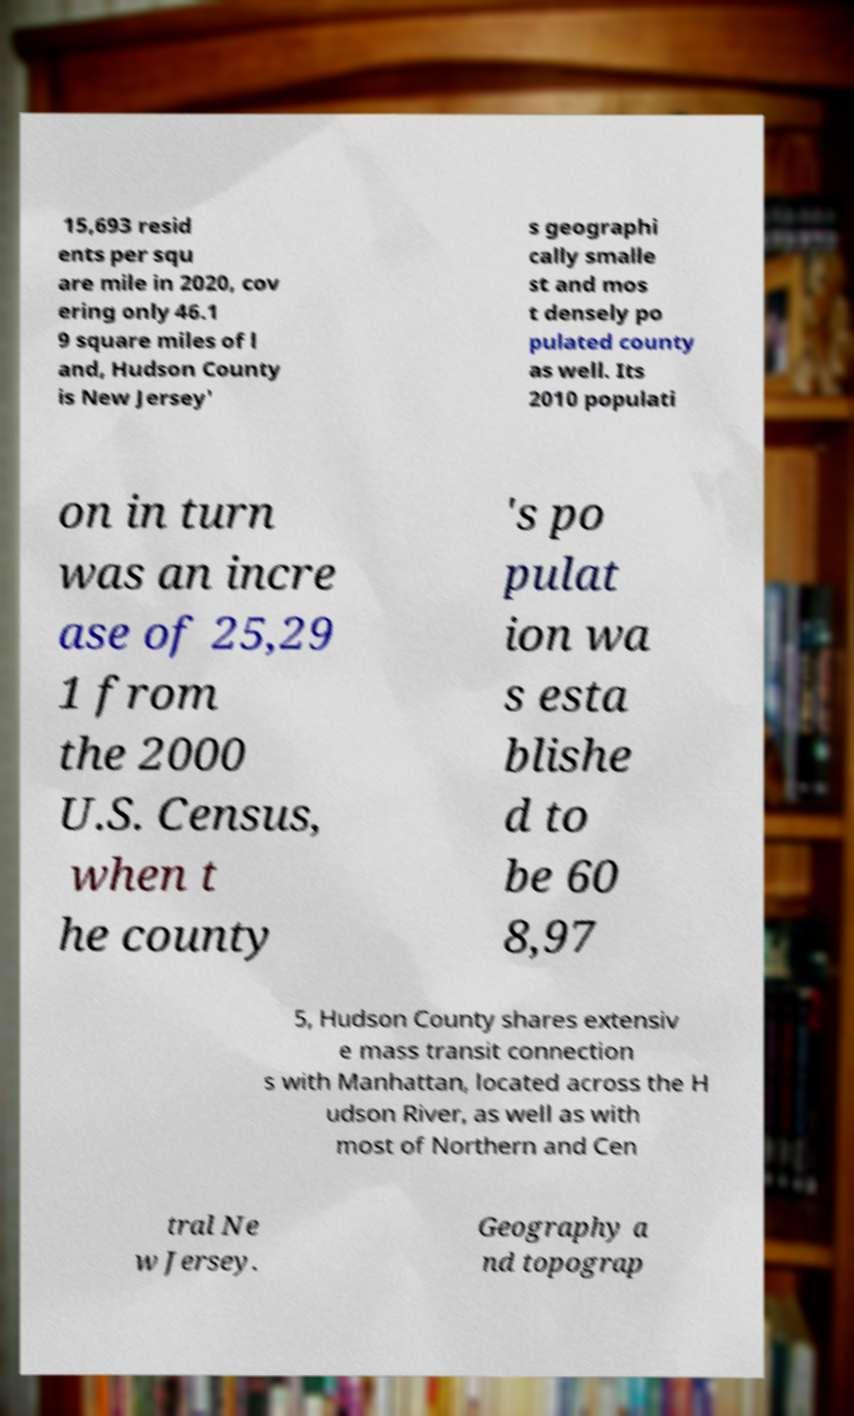Could you extract and type out the text from this image? 15,693 resid ents per squ are mile in 2020, cov ering only 46.1 9 square miles of l and, Hudson County is New Jersey' s geographi cally smalle st and mos t densely po pulated county as well. Its 2010 populati on in turn was an incre ase of 25,29 1 from the 2000 U.S. Census, when t he county 's po pulat ion wa s esta blishe d to be 60 8,97 5, Hudson County shares extensiv e mass transit connection s with Manhattan, located across the H udson River, as well as with most of Northern and Cen tral Ne w Jersey. Geography a nd topograp 